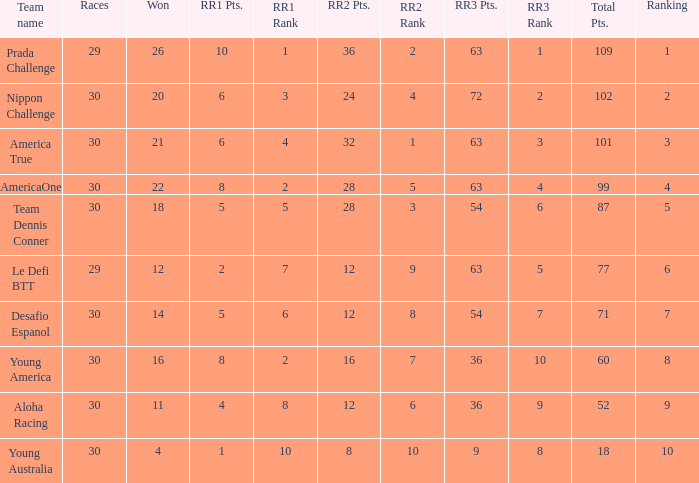Name the races for the prada challenge 29.0. 